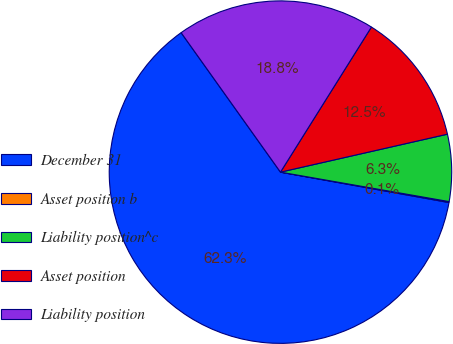Convert chart. <chart><loc_0><loc_0><loc_500><loc_500><pie_chart><fcel>December 31<fcel>Asset position b<fcel>Liability position^c<fcel>Asset position<fcel>Liability position<nl><fcel>62.3%<fcel>0.09%<fcel>6.31%<fcel>12.53%<fcel>18.76%<nl></chart> 